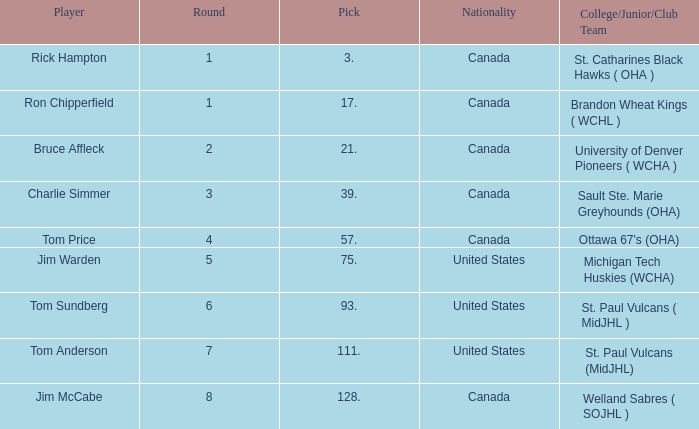Can you tell me the College/Junior/Club Team that has the Round of 4? Ottawa 67's (OHA). 